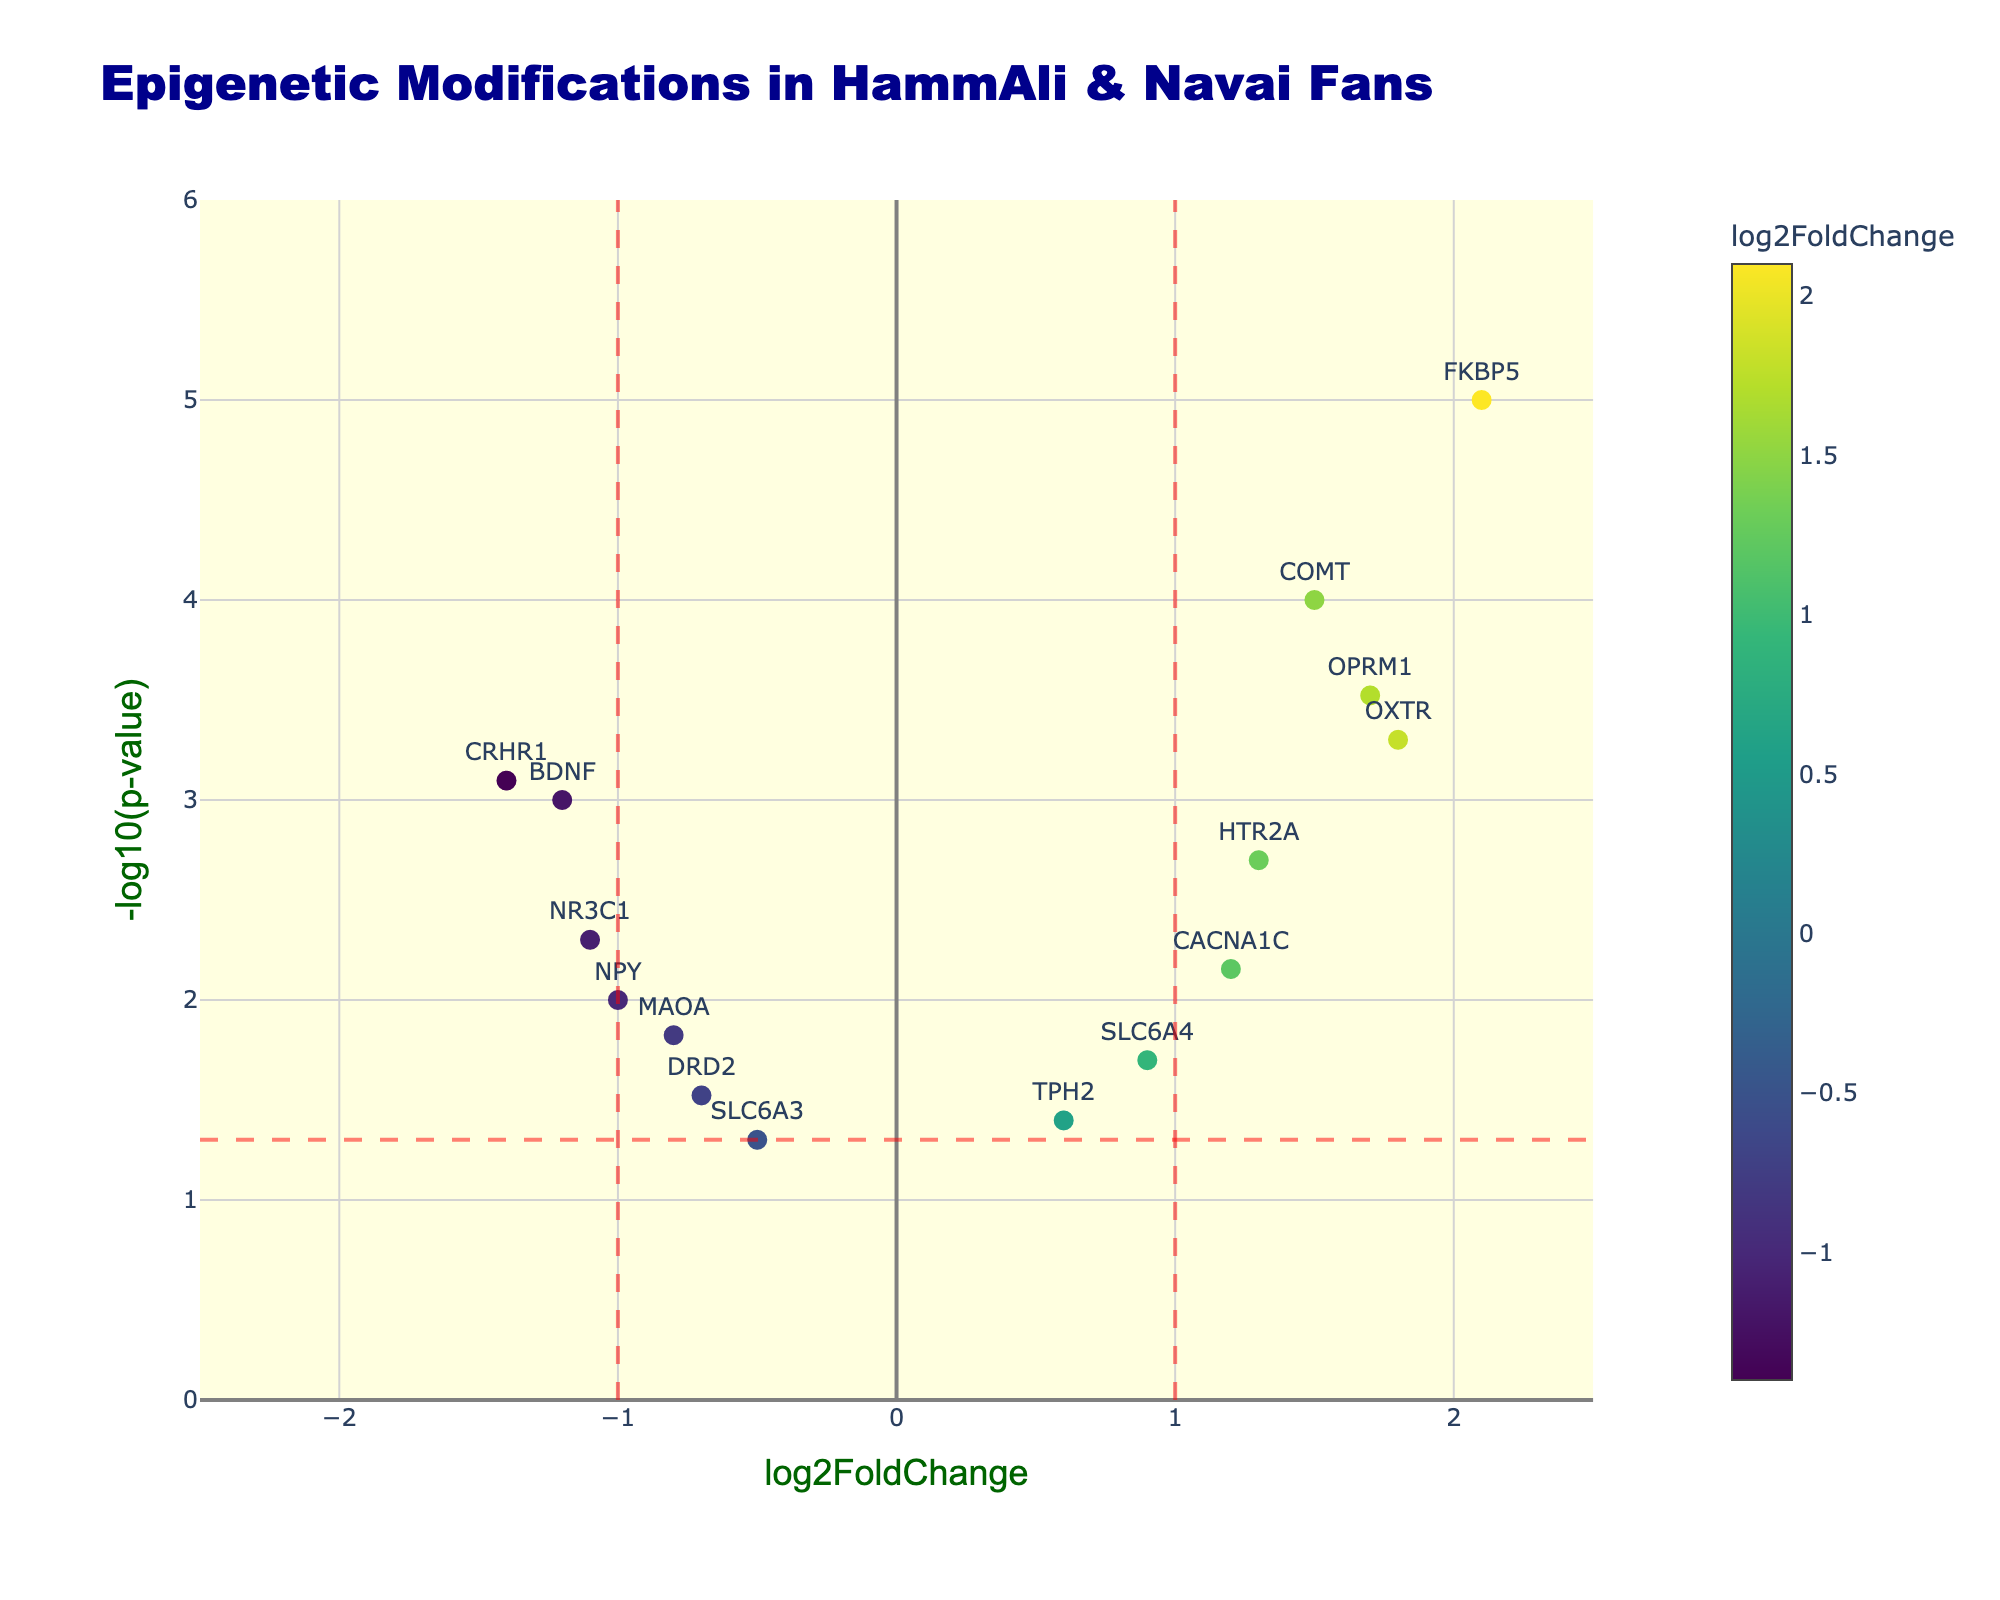How many genes have a log2FoldChange greater than 1? To determine the number of genes with a log2FoldChange greater than 1, you need to count instances where log2FoldChange values exceed 1. The figure highlights each gene's log2FoldChange, and those containing values >1 are highlighted. Visual check shows genes: OXTR, COMT, FKBP5, HTR2A, OPRM1, and CACNA1C. Hence, there are 6 genes.
Answer: 6 Which gene has the highest log2FoldChange? Identify the data point with the highest x-axis value. The plot presents each gene with its log2FoldChange value on the x-axis. Visual examination indicates FKBP5 as the gene with the highest log2FoldChange, as it is farthest to the right.
Answer: FKBP5 What is the title of the plot? The title of the plot is typically stated prominently at the top of the figure. Observing the top section of the figure, the title is clearly stated.
Answer: Epigenetic Modifications in HammAli & Navai Fans How many genes have a p-value less than 0.01? To find the number of genes with a p-value less than 0.01, check each gene's -log10(p-value) on the y-axis. Values corresponding to p < 0.01 will have -log10(p-value) above 2. Visual inspection shows genes BDNF, OXTR, COMT, NR3C1, FKBP5, HTR2A, CRHR1, OPRM1, and CACNA1C meeting the criteria. Count them to determine there are 9 genes.
Answer: 9 Which genes are significantly differentially expressed (log2FoldChange > 1 and p < 0.05)? Significant genes will have log2FoldChange values greater than 1 and p-values less than 0.05. Visual assessment of the right side above the horizontal significance line shows OXTR, COMT, FKBP5, HTR2A, OPRM1, and CACNA1C meeting these criteria.
Answer: OXTR, COMT, FKBP5, HTR2A, OPRM1, CACNA1C Which gene has the lowest p-value? The gene with the lowest p-value will have the highest -log10(p-value) value on the y-axis. By looking for the highest point in the plot, FKBP5 is the gene with the highest y-value and, thus, the lowest p-value.
Answer: FKBP5 How many genes have negative log2FoldChange values? Negative log2FoldChange values are found on the left of the vertical axis. Visually count the data points on the side where log2FoldChange is negative (left side). Genes like BDNF, DRD2, NR3C1, CRHR1, MAOA, NPY, and SLC6A3 appear on the left, making the count 7.
Answer: 7 Which gene is closest to the threshold of log2FoldChange = 1? Locate the gene nearest to the vertical line representing log2FoldChange = 1 by nearest proximity to it. The visual proximity suggests CACNA1C is virtually touching this threshold line, making it the closest.
Answer: CACNA1C What is the log2FoldChange of the gene OPRM1? Identify the specific gene on the plot and read its corresponding x-axis value. OPRM1 is marked on the x-axis, and the log2FoldChange value can be approximated directly from its position. OPRM1 is around 1.7.
Answer: 1.7 